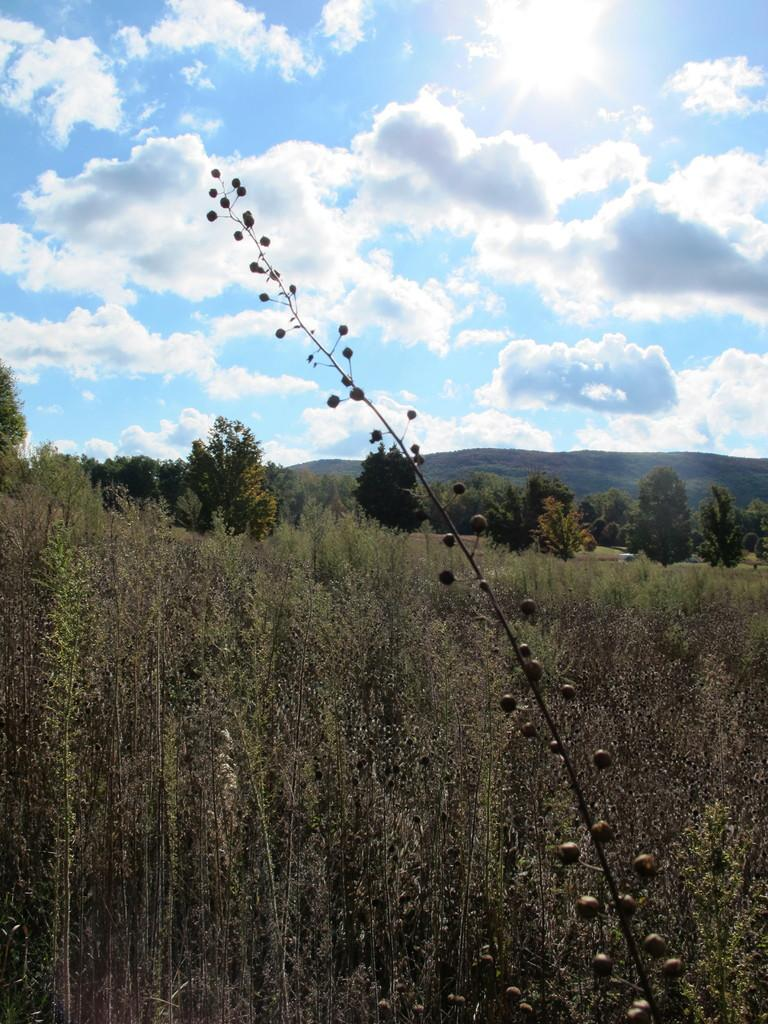What type of vegetation can be seen in the image? There are many plants and trees in the image. What is visible in the background of the image? There is a mountain in the background of the image. What can be seen in the sky at the top of the image? There are clouds in the sky at the top of the image. How many fingers does the grandfather have in the image? There is no grandfather or fingers present in the image. 